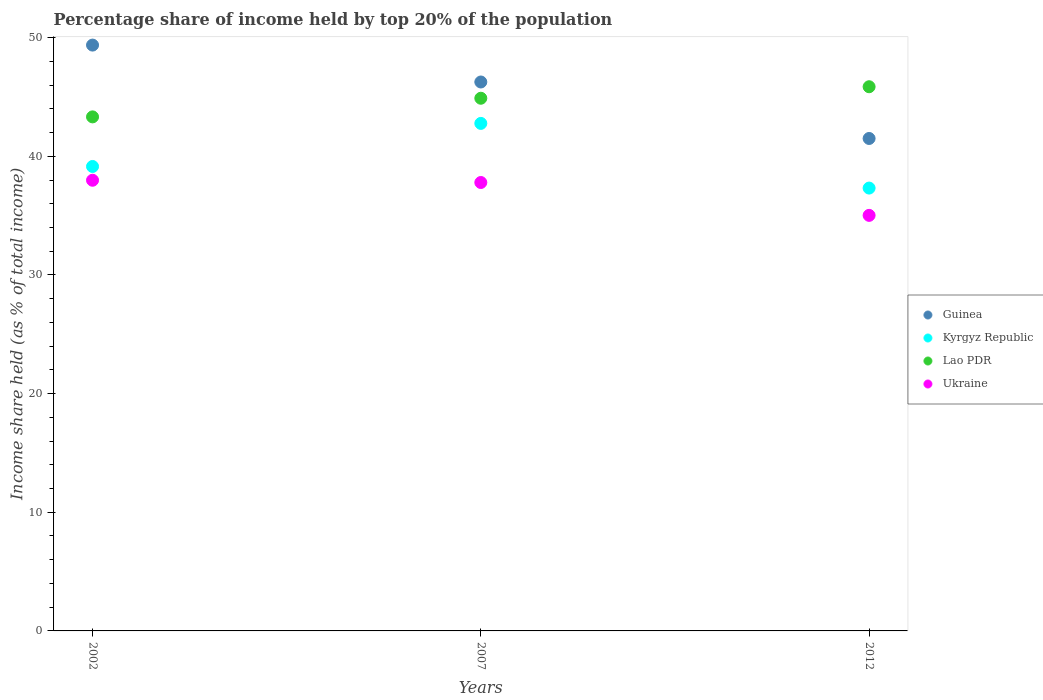How many different coloured dotlines are there?
Give a very brief answer. 4. What is the percentage share of income held by top 20% of the population in Ukraine in 2002?
Offer a terse response. 37.98. Across all years, what is the maximum percentage share of income held by top 20% of the population in Kyrgyz Republic?
Ensure brevity in your answer.  42.77. Across all years, what is the minimum percentage share of income held by top 20% of the population in Kyrgyz Republic?
Your answer should be compact. 37.32. What is the total percentage share of income held by top 20% of the population in Ukraine in the graph?
Keep it short and to the point. 110.79. What is the difference between the percentage share of income held by top 20% of the population in Kyrgyz Republic in 2002 and that in 2012?
Offer a very short reply. 1.82. What is the difference between the percentage share of income held by top 20% of the population in Ukraine in 2007 and the percentage share of income held by top 20% of the population in Kyrgyz Republic in 2012?
Provide a succinct answer. 0.47. What is the average percentage share of income held by top 20% of the population in Guinea per year?
Keep it short and to the point. 45.71. In the year 2007, what is the difference between the percentage share of income held by top 20% of the population in Kyrgyz Republic and percentage share of income held by top 20% of the population in Lao PDR?
Your answer should be compact. -2.12. What is the ratio of the percentage share of income held by top 20% of the population in Guinea in 2002 to that in 2012?
Your answer should be very brief. 1.19. Is the percentage share of income held by top 20% of the population in Lao PDR in 2002 less than that in 2012?
Provide a short and direct response. Yes. What is the difference between the highest and the second highest percentage share of income held by top 20% of the population in Kyrgyz Republic?
Offer a terse response. 3.63. What is the difference between the highest and the lowest percentage share of income held by top 20% of the population in Lao PDR?
Ensure brevity in your answer.  2.54. Is the sum of the percentage share of income held by top 20% of the population in Ukraine in 2002 and 2012 greater than the maximum percentage share of income held by top 20% of the population in Kyrgyz Republic across all years?
Give a very brief answer. Yes. Is it the case that in every year, the sum of the percentage share of income held by top 20% of the population in Kyrgyz Republic and percentage share of income held by top 20% of the population in Lao PDR  is greater than the percentage share of income held by top 20% of the population in Ukraine?
Provide a succinct answer. Yes. Is the percentage share of income held by top 20% of the population in Guinea strictly less than the percentage share of income held by top 20% of the population in Kyrgyz Republic over the years?
Provide a short and direct response. No. How many dotlines are there?
Your answer should be very brief. 4. What is the difference between two consecutive major ticks on the Y-axis?
Make the answer very short. 10. Does the graph contain any zero values?
Ensure brevity in your answer.  No. Does the graph contain grids?
Ensure brevity in your answer.  No. How are the legend labels stacked?
Ensure brevity in your answer.  Vertical. What is the title of the graph?
Your answer should be compact. Percentage share of income held by top 20% of the population. What is the label or title of the X-axis?
Offer a very short reply. Years. What is the label or title of the Y-axis?
Make the answer very short. Income share held (as % of total income). What is the Income share held (as % of total income) in Guinea in 2002?
Ensure brevity in your answer.  49.37. What is the Income share held (as % of total income) in Kyrgyz Republic in 2002?
Offer a terse response. 39.14. What is the Income share held (as % of total income) of Lao PDR in 2002?
Give a very brief answer. 43.32. What is the Income share held (as % of total income) in Ukraine in 2002?
Make the answer very short. 37.98. What is the Income share held (as % of total income) of Guinea in 2007?
Provide a succinct answer. 46.26. What is the Income share held (as % of total income) in Kyrgyz Republic in 2007?
Your response must be concise. 42.77. What is the Income share held (as % of total income) in Lao PDR in 2007?
Ensure brevity in your answer.  44.89. What is the Income share held (as % of total income) in Ukraine in 2007?
Give a very brief answer. 37.79. What is the Income share held (as % of total income) of Guinea in 2012?
Keep it short and to the point. 41.5. What is the Income share held (as % of total income) of Kyrgyz Republic in 2012?
Ensure brevity in your answer.  37.32. What is the Income share held (as % of total income) in Lao PDR in 2012?
Give a very brief answer. 45.86. What is the Income share held (as % of total income) in Ukraine in 2012?
Provide a succinct answer. 35.02. Across all years, what is the maximum Income share held (as % of total income) in Guinea?
Ensure brevity in your answer.  49.37. Across all years, what is the maximum Income share held (as % of total income) of Kyrgyz Republic?
Your answer should be very brief. 42.77. Across all years, what is the maximum Income share held (as % of total income) of Lao PDR?
Offer a terse response. 45.86. Across all years, what is the maximum Income share held (as % of total income) of Ukraine?
Offer a terse response. 37.98. Across all years, what is the minimum Income share held (as % of total income) of Guinea?
Your answer should be very brief. 41.5. Across all years, what is the minimum Income share held (as % of total income) of Kyrgyz Republic?
Ensure brevity in your answer.  37.32. Across all years, what is the minimum Income share held (as % of total income) in Lao PDR?
Your answer should be compact. 43.32. Across all years, what is the minimum Income share held (as % of total income) of Ukraine?
Your answer should be compact. 35.02. What is the total Income share held (as % of total income) in Guinea in the graph?
Your answer should be very brief. 137.13. What is the total Income share held (as % of total income) in Kyrgyz Republic in the graph?
Provide a short and direct response. 119.23. What is the total Income share held (as % of total income) in Lao PDR in the graph?
Provide a succinct answer. 134.07. What is the total Income share held (as % of total income) in Ukraine in the graph?
Provide a short and direct response. 110.79. What is the difference between the Income share held (as % of total income) in Guinea in 2002 and that in 2007?
Keep it short and to the point. 3.11. What is the difference between the Income share held (as % of total income) of Kyrgyz Republic in 2002 and that in 2007?
Offer a terse response. -3.63. What is the difference between the Income share held (as % of total income) of Lao PDR in 2002 and that in 2007?
Ensure brevity in your answer.  -1.57. What is the difference between the Income share held (as % of total income) in Ukraine in 2002 and that in 2007?
Your answer should be compact. 0.19. What is the difference between the Income share held (as % of total income) of Guinea in 2002 and that in 2012?
Provide a succinct answer. 7.87. What is the difference between the Income share held (as % of total income) in Kyrgyz Republic in 2002 and that in 2012?
Make the answer very short. 1.82. What is the difference between the Income share held (as % of total income) in Lao PDR in 2002 and that in 2012?
Keep it short and to the point. -2.54. What is the difference between the Income share held (as % of total income) of Ukraine in 2002 and that in 2012?
Give a very brief answer. 2.96. What is the difference between the Income share held (as % of total income) in Guinea in 2007 and that in 2012?
Give a very brief answer. 4.76. What is the difference between the Income share held (as % of total income) of Kyrgyz Republic in 2007 and that in 2012?
Make the answer very short. 5.45. What is the difference between the Income share held (as % of total income) of Lao PDR in 2007 and that in 2012?
Your answer should be compact. -0.97. What is the difference between the Income share held (as % of total income) of Ukraine in 2007 and that in 2012?
Your answer should be compact. 2.77. What is the difference between the Income share held (as % of total income) in Guinea in 2002 and the Income share held (as % of total income) in Kyrgyz Republic in 2007?
Keep it short and to the point. 6.6. What is the difference between the Income share held (as % of total income) of Guinea in 2002 and the Income share held (as % of total income) of Lao PDR in 2007?
Provide a short and direct response. 4.48. What is the difference between the Income share held (as % of total income) in Guinea in 2002 and the Income share held (as % of total income) in Ukraine in 2007?
Provide a short and direct response. 11.58. What is the difference between the Income share held (as % of total income) in Kyrgyz Republic in 2002 and the Income share held (as % of total income) in Lao PDR in 2007?
Offer a terse response. -5.75. What is the difference between the Income share held (as % of total income) of Kyrgyz Republic in 2002 and the Income share held (as % of total income) of Ukraine in 2007?
Provide a succinct answer. 1.35. What is the difference between the Income share held (as % of total income) of Lao PDR in 2002 and the Income share held (as % of total income) of Ukraine in 2007?
Your answer should be very brief. 5.53. What is the difference between the Income share held (as % of total income) in Guinea in 2002 and the Income share held (as % of total income) in Kyrgyz Republic in 2012?
Your answer should be very brief. 12.05. What is the difference between the Income share held (as % of total income) in Guinea in 2002 and the Income share held (as % of total income) in Lao PDR in 2012?
Provide a succinct answer. 3.51. What is the difference between the Income share held (as % of total income) of Guinea in 2002 and the Income share held (as % of total income) of Ukraine in 2012?
Your answer should be compact. 14.35. What is the difference between the Income share held (as % of total income) in Kyrgyz Republic in 2002 and the Income share held (as % of total income) in Lao PDR in 2012?
Offer a very short reply. -6.72. What is the difference between the Income share held (as % of total income) of Kyrgyz Republic in 2002 and the Income share held (as % of total income) of Ukraine in 2012?
Make the answer very short. 4.12. What is the difference between the Income share held (as % of total income) of Guinea in 2007 and the Income share held (as % of total income) of Kyrgyz Republic in 2012?
Make the answer very short. 8.94. What is the difference between the Income share held (as % of total income) of Guinea in 2007 and the Income share held (as % of total income) of Lao PDR in 2012?
Offer a very short reply. 0.4. What is the difference between the Income share held (as % of total income) in Guinea in 2007 and the Income share held (as % of total income) in Ukraine in 2012?
Give a very brief answer. 11.24. What is the difference between the Income share held (as % of total income) of Kyrgyz Republic in 2007 and the Income share held (as % of total income) of Lao PDR in 2012?
Your answer should be compact. -3.09. What is the difference between the Income share held (as % of total income) of Kyrgyz Republic in 2007 and the Income share held (as % of total income) of Ukraine in 2012?
Offer a terse response. 7.75. What is the difference between the Income share held (as % of total income) in Lao PDR in 2007 and the Income share held (as % of total income) in Ukraine in 2012?
Your answer should be very brief. 9.87. What is the average Income share held (as % of total income) of Guinea per year?
Offer a very short reply. 45.71. What is the average Income share held (as % of total income) in Kyrgyz Republic per year?
Give a very brief answer. 39.74. What is the average Income share held (as % of total income) in Lao PDR per year?
Your answer should be compact. 44.69. What is the average Income share held (as % of total income) in Ukraine per year?
Provide a short and direct response. 36.93. In the year 2002, what is the difference between the Income share held (as % of total income) of Guinea and Income share held (as % of total income) of Kyrgyz Republic?
Make the answer very short. 10.23. In the year 2002, what is the difference between the Income share held (as % of total income) in Guinea and Income share held (as % of total income) in Lao PDR?
Your answer should be compact. 6.05. In the year 2002, what is the difference between the Income share held (as % of total income) of Guinea and Income share held (as % of total income) of Ukraine?
Your answer should be compact. 11.39. In the year 2002, what is the difference between the Income share held (as % of total income) in Kyrgyz Republic and Income share held (as % of total income) in Lao PDR?
Your response must be concise. -4.18. In the year 2002, what is the difference between the Income share held (as % of total income) in Kyrgyz Republic and Income share held (as % of total income) in Ukraine?
Keep it short and to the point. 1.16. In the year 2002, what is the difference between the Income share held (as % of total income) of Lao PDR and Income share held (as % of total income) of Ukraine?
Make the answer very short. 5.34. In the year 2007, what is the difference between the Income share held (as % of total income) of Guinea and Income share held (as % of total income) of Kyrgyz Republic?
Offer a very short reply. 3.49. In the year 2007, what is the difference between the Income share held (as % of total income) of Guinea and Income share held (as % of total income) of Lao PDR?
Give a very brief answer. 1.37. In the year 2007, what is the difference between the Income share held (as % of total income) of Guinea and Income share held (as % of total income) of Ukraine?
Offer a terse response. 8.47. In the year 2007, what is the difference between the Income share held (as % of total income) in Kyrgyz Republic and Income share held (as % of total income) in Lao PDR?
Your response must be concise. -2.12. In the year 2007, what is the difference between the Income share held (as % of total income) in Kyrgyz Republic and Income share held (as % of total income) in Ukraine?
Give a very brief answer. 4.98. In the year 2012, what is the difference between the Income share held (as % of total income) in Guinea and Income share held (as % of total income) in Kyrgyz Republic?
Your answer should be compact. 4.18. In the year 2012, what is the difference between the Income share held (as % of total income) in Guinea and Income share held (as % of total income) in Lao PDR?
Provide a short and direct response. -4.36. In the year 2012, what is the difference between the Income share held (as % of total income) of Guinea and Income share held (as % of total income) of Ukraine?
Your response must be concise. 6.48. In the year 2012, what is the difference between the Income share held (as % of total income) in Kyrgyz Republic and Income share held (as % of total income) in Lao PDR?
Your answer should be compact. -8.54. In the year 2012, what is the difference between the Income share held (as % of total income) of Lao PDR and Income share held (as % of total income) of Ukraine?
Provide a succinct answer. 10.84. What is the ratio of the Income share held (as % of total income) of Guinea in 2002 to that in 2007?
Provide a short and direct response. 1.07. What is the ratio of the Income share held (as % of total income) in Kyrgyz Republic in 2002 to that in 2007?
Keep it short and to the point. 0.92. What is the ratio of the Income share held (as % of total income) in Lao PDR in 2002 to that in 2007?
Provide a short and direct response. 0.96. What is the ratio of the Income share held (as % of total income) in Guinea in 2002 to that in 2012?
Keep it short and to the point. 1.19. What is the ratio of the Income share held (as % of total income) in Kyrgyz Republic in 2002 to that in 2012?
Your answer should be compact. 1.05. What is the ratio of the Income share held (as % of total income) of Lao PDR in 2002 to that in 2012?
Your answer should be very brief. 0.94. What is the ratio of the Income share held (as % of total income) in Ukraine in 2002 to that in 2012?
Offer a very short reply. 1.08. What is the ratio of the Income share held (as % of total income) of Guinea in 2007 to that in 2012?
Provide a short and direct response. 1.11. What is the ratio of the Income share held (as % of total income) in Kyrgyz Republic in 2007 to that in 2012?
Your answer should be very brief. 1.15. What is the ratio of the Income share held (as % of total income) in Lao PDR in 2007 to that in 2012?
Ensure brevity in your answer.  0.98. What is the ratio of the Income share held (as % of total income) of Ukraine in 2007 to that in 2012?
Your answer should be compact. 1.08. What is the difference between the highest and the second highest Income share held (as % of total income) of Guinea?
Provide a succinct answer. 3.11. What is the difference between the highest and the second highest Income share held (as % of total income) of Kyrgyz Republic?
Keep it short and to the point. 3.63. What is the difference between the highest and the second highest Income share held (as % of total income) of Ukraine?
Provide a short and direct response. 0.19. What is the difference between the highest and the lowest Income share held (as % of total income) in Guinea?
Your answer should be compact. 7.87. What is the difference between the highest and the lowest Income share held (as % of total income) in Kyrgyz Republic?
Provide a short and direct response. 5.45. What is the difference between the highest and the lowest Income share held (as % of total income) of Lao PDR?
Ensure brevity in your answer.  2.54. What is the difference between the highest and the lowest Income share held (as % of total income) in Ukraine?
Give a very brief answer. 2.96. 